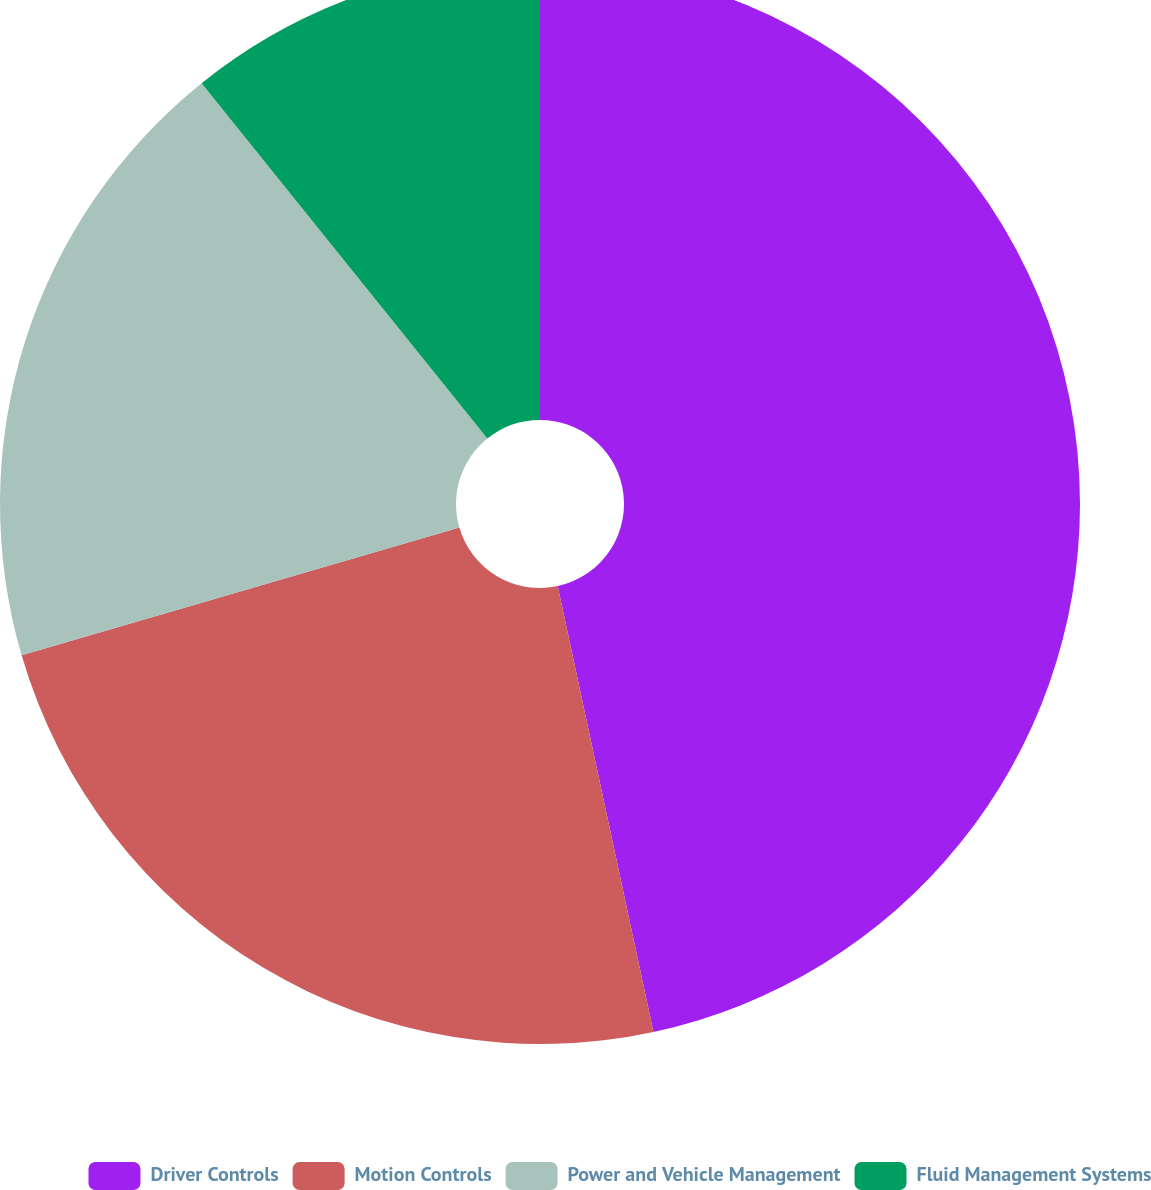<chart> <loc_0><loc_0><loc_500><loc_500><pie_chart><fcel>Driver Controls<fcel>Motion Controls<fcel>Power and Vehicle Management<fcel>Fluid Management Systems<nl><fcel>46.63%<fcel>23.85%<fcel>18.74%<fcel>10.78%<nl></chart> 